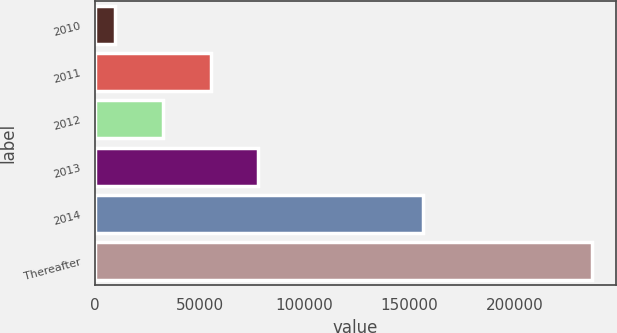<chart> <loc_0><loc_0><loc_500><loc_500><bar_chart><fcel>2010<fcel>2011<fcel>2012<fcel>2013<fcel>2014<fcel>Thereafter<nl><fcel>9860<fcel>55238.6<fcel>32549.3<fcel>77927.9<fcel>156364<fcel>236753<nl></chart> 